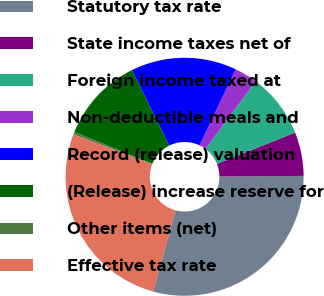Convert chart to OTSL. <chart><loc_0><loc_0><loc_500><loc_500><pie_chart><fcel>Statutory tax rate<fcel>State income taxes net of<fcel>Foreign income taxed at<fcel>Non-deductible meals and<fcel>Record (release) valuation<fcel>(Release) increase reserve for<fcel>Other items (net)<fcel>Effective tax rate<nl><fcel>29.36%<fcel>5.94%<fcel>8.75%<fcel>3.13%<fcel>14.37%<fcel>11.56%<fcel>0.32%<fcel>26.55%<nl></chart> 